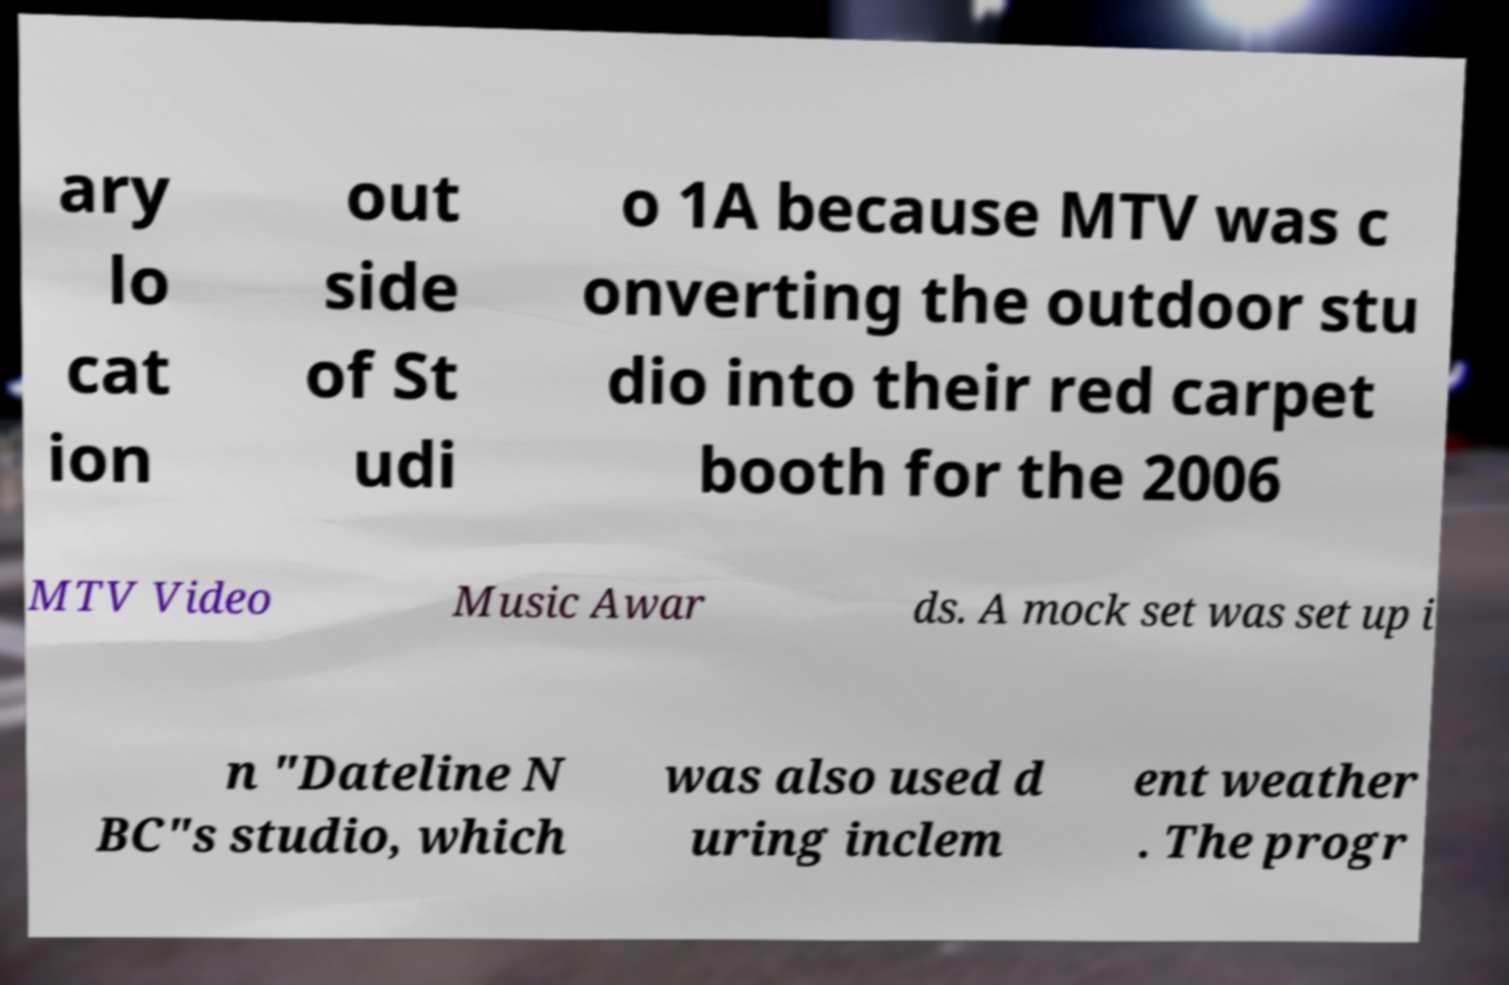Please identify and transcribe the text found in this image. ary lo cat ion out side of St udi o 1A because MTV was c onverting the outdoor stu dio into their red carpet booth for the 2006 MTV Video Music Awar ds. A mock set was set up i n "Dateline N BC"s studio, which was also used d uring inclem ent weather . The progr 